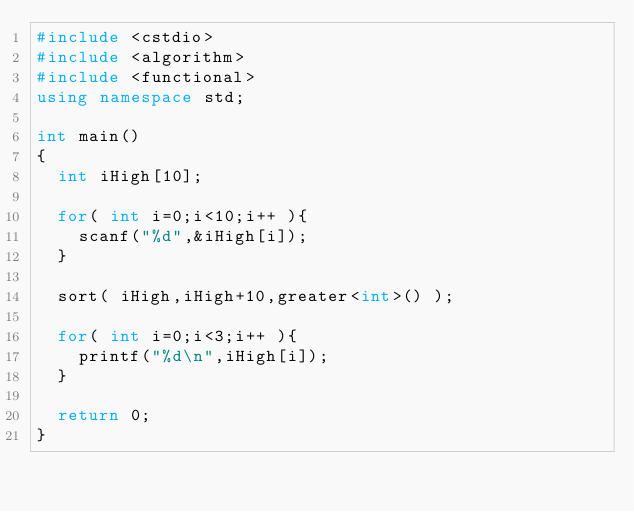Convert code to text. <code><loc_0><loc_0><loc_500><loc_500><_C++_>#include <cstdio>
#include <algorithm>
#include <functional>
using namespace std;

int main()
{
	int iHigh[10];

	for( int i=0;i<10;i++ ){
		scanf("%d",&iHigh[i]);
	}

	sort( iHigh,iHigh+10,greater<int>() );

	for( int i=0;i<3;i++ ){
		printf("%d\n",iHigh[i]);
	}

	return 0;
}</code> 